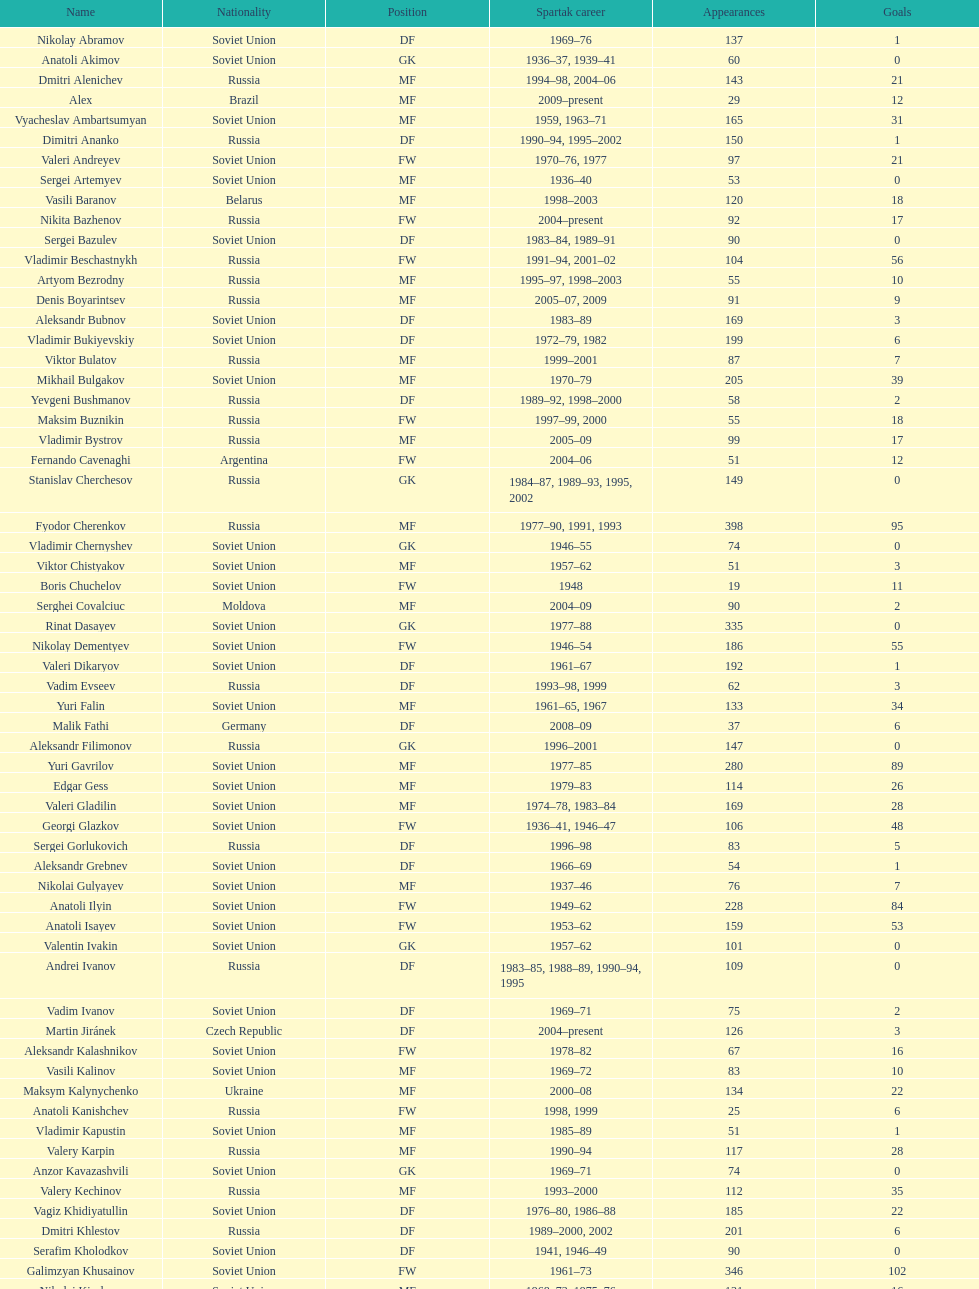Which player has the most appearances with the club? Fyodor Cherenkov. 